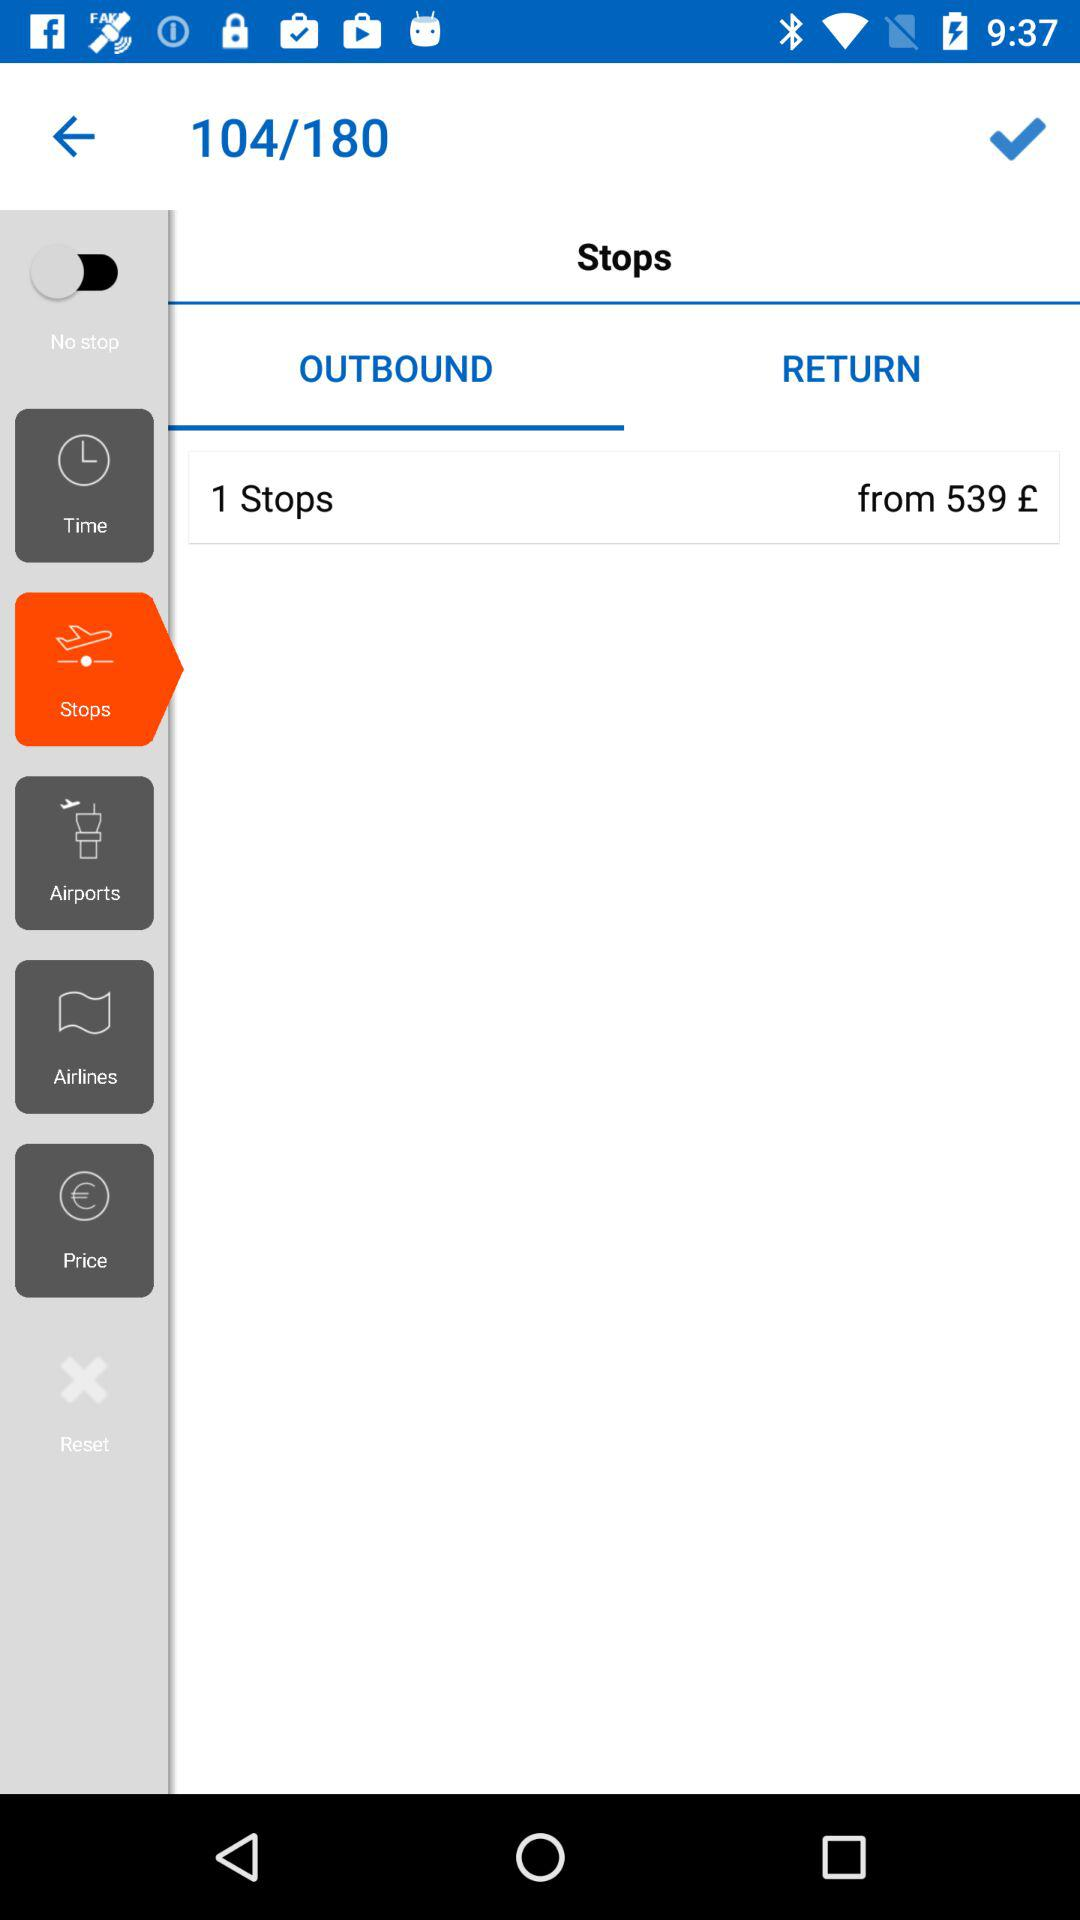How many stops are there? There is 1 stop. 